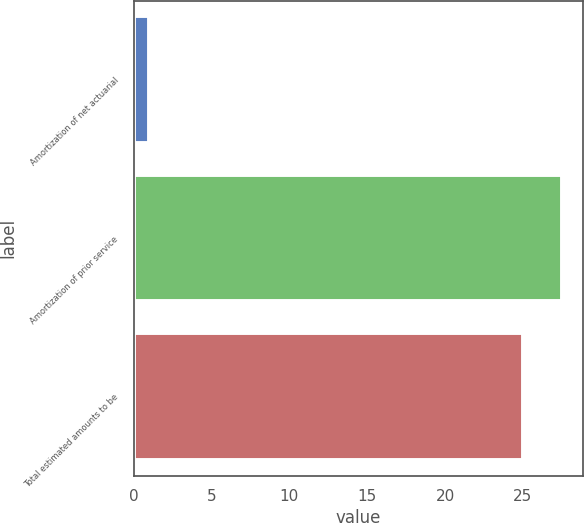Convert chart. <chart><loc_0><loc_0><loc_500><loc_500><bar_chart><fcel>Amortization of net actuarial<fcel>Amortization of prior service<fcel>Total estimated amounts to be<nl><fcel>1<fcel>27.5<fcel>25<nl></chart> 